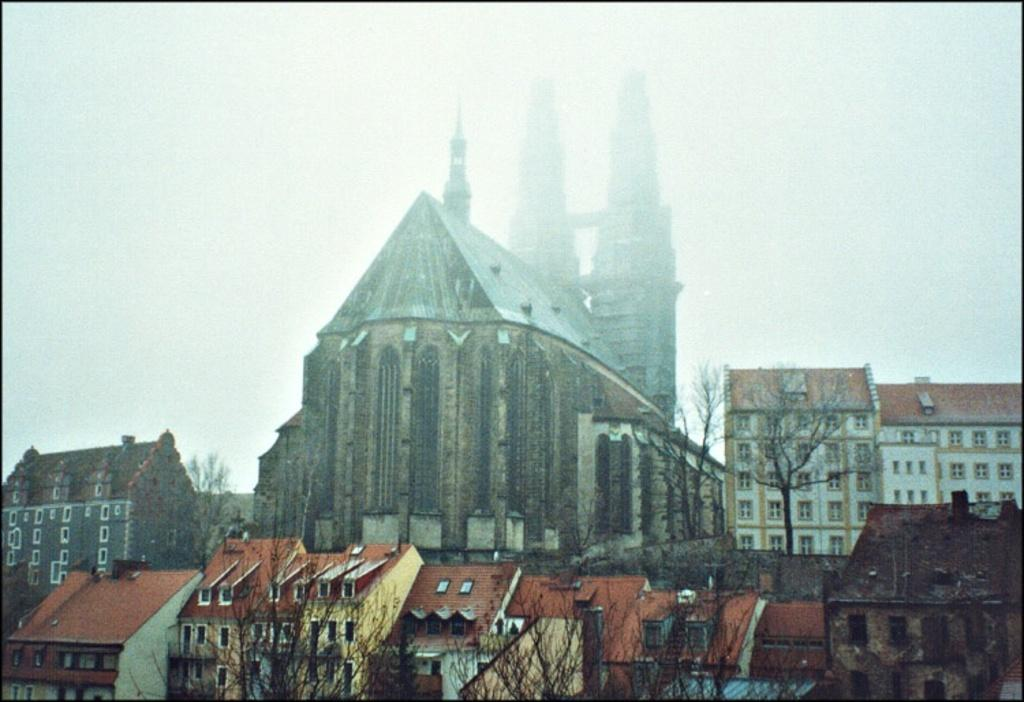What type of structures are visible in the image? There are buildings in the image. What type of vegetation is present at the bottom side of the image? There are trees at the bottom side of the image. What type of pet can be seen in the hospital in the image? There is no pet or hospital present in the image; it only features buildings and trees. 